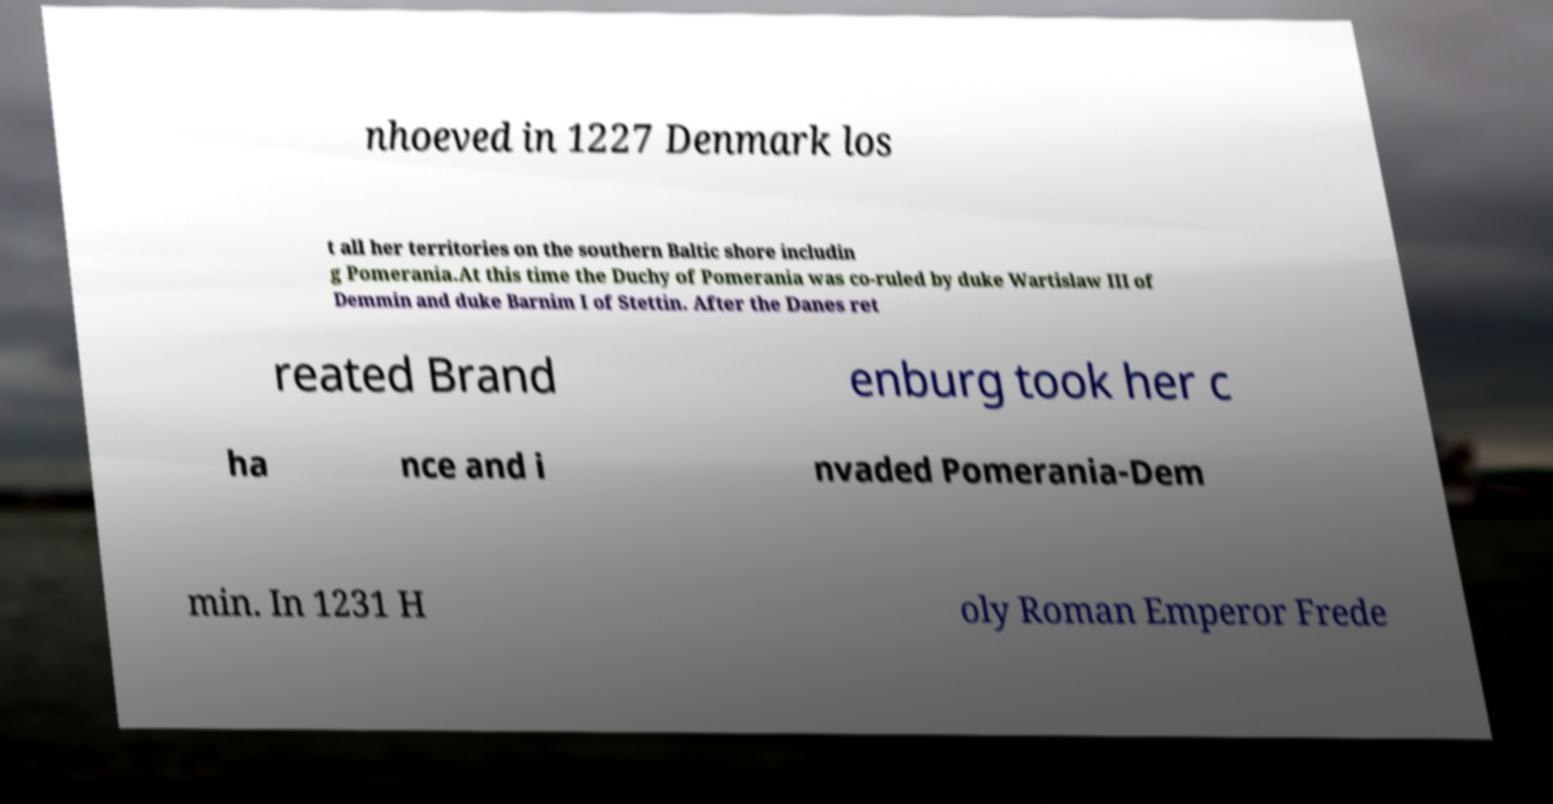Could you assist in decoding the text presented in this image and type it out clearly? nhoeved in 1227 Denmark los t all her territories on the southern Baltic shore includin g Pomerania.At this time the Duchy of Pomerania was co-ruled by duke Wartislaw III of Demmin and duke Barnim I of Stettin. After the Danes ret reated Brand enburg took her c ha nce and i nvaded Pomerania-Dem min. In 1231 H oly Roman Emperor Frede 